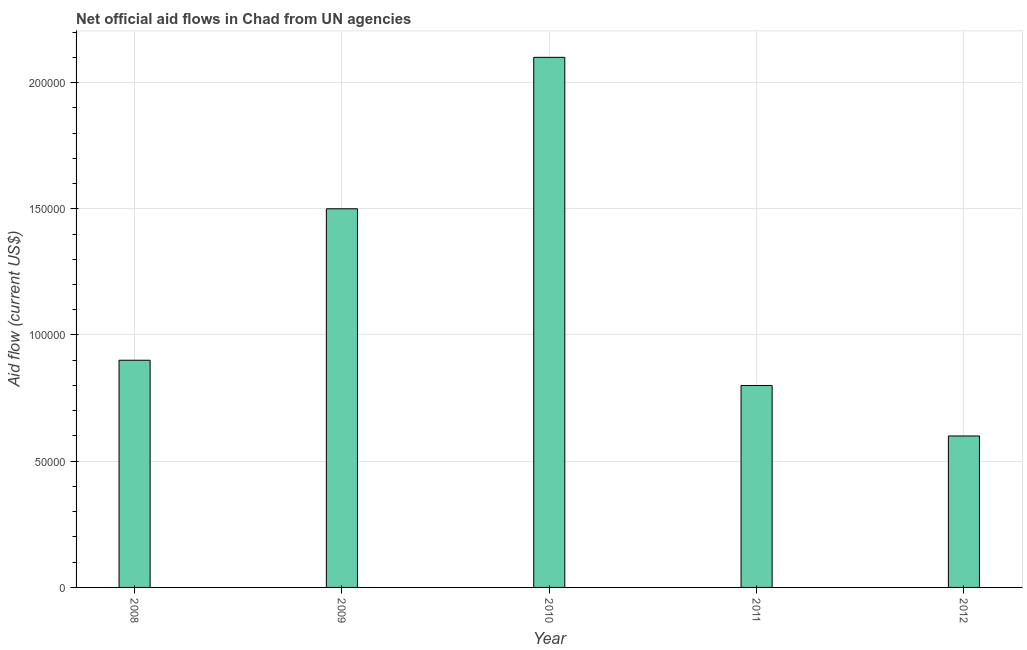Does the graph contain any zero values?
Give a very brief answer. No. Does the graph contain grids?
Offer a terse response. Yes. What is the title of the graph?
Your answer should be compact. Net official aid flows in Chad from UN agencies. What is the label or title of the X-axis?
Offer a terse response. Year. What is the label or title of the Y-axis?
Your answer should be very brief. Aid flow (current US$). What is the net official flows from un agencies in 2012?
Offer a very short reply. 6.00e+04. In which year was the net official flows from un agencies minimum?
Make the answer very short. 2012. What is the sum of the net official flows from un agencies?
Offer a terse response. 5.90e+05. What is the difference between the net official flows from un agencies in 2009 and 2011?
Your answer should be very brief. 7.00e+04. What is the average net official flows from un agencies per year?
Offer a terse response. 1.18e+05. What is the median net official flows from un agencies?
Keep it short and to the point. 9.00e+04. Do a majority of the years between 2009 and 2012 (inclusive) have net official flows from un agencies greater than 210000 US$?
Ensure brevity in your answer.  No. Is the difference between the net official flows from un agencies in 2010 and 2011 greater than the difference between any two years?
Keep it short and to the point. No. What is the difference between the highest and the second highest net official flows from un agencies?
Offer a terse response. 6.00e+04. What is the difference between the highest and the lowest net official flows from un agencies?
Provide a short and direct response. 1.50e+05. In how many years, is the net official flows from un agencies greater than the average net official flows from un agencies taken over all years?
Your response must be concise. 2. How many bars are there?
Give a very brief answer. 5. How many years are there in the graph?
Offer a terse response. 5. What is the difference between two consecutive major ticks on the Y-axis?
Provide a short and direct response. 5.00e+04. Are the values on the major ticks of Y-axis written in scientific E-notation?
Your answer should be very brief. No. What is the Aid flow (current US$) in 2009?
Ensure brevity in your answer.  1.50e+05. What is the Aid flow (current US$) of 2010?
Offer a very short reply. 2.10e+05. What is the Aid flow (current US$) in 2012?
Provide a short and direct response. 6.00e+04. What is the difference between the Aid flow (current US$) in 2008 and 2011?
Offer a terse response. 10000. What is the difference between the Aid flow (current US$) in 2008 and 2012?
Provide a succinct answer. 3.00e+04. What is the difference between the Aid flow (current US$) in 2009 and 2010?
Your answer should be compact. -6.00e+04. What is the difference between the Aid flow (current US$) in 2009 and 2011?
Keep it short and to the point. 7.00e+04. What is the difference between the Aid flow (current US$) in 2009 and 2012?
Keep it short and to the point. 9.00e+04. What is the difference between the Aid flow (current US$) in 2010 and 2011?
Offer a very short reply. 1.30e+05. What is the difference between the Aid flow (current US$) in 2010 and 2012?
Provide a short and direct response. 1.50e+05. What is the ratio of the Aid flow (current US$) in 2008 to that in 2010?
Keep it short and to the point. 0.43. What is the ratio of the Aid flow (current US$) in 2008 to that in 2012?
Provide a succinct answer. 1.5. What is the ratio of the Aid flow (current US$) in 2009 to that in 2010?
Provide a succinct answer. 0.71. What is the ratio of the Aid flow (current US$) in 2009 to that in 2011?
Your answer should be very brief. 1.88. What is the ratio of the Aid flow (current US$) in 2009 to that in 2012?
Offer a terse response. 2.5. What is the ratio of the Aid flow (current US$) in 2010 to that in 2011?
Provide a succinct answer. 2.62. What is the ratio of the Aid flow (current US$) in 2010 to that in 2012?
Keep it short and to the point. 3.5. What is the ratio of the Aid flow (current US$) in 2011 to that in 2012?
Make the answer very short. 1.33. 